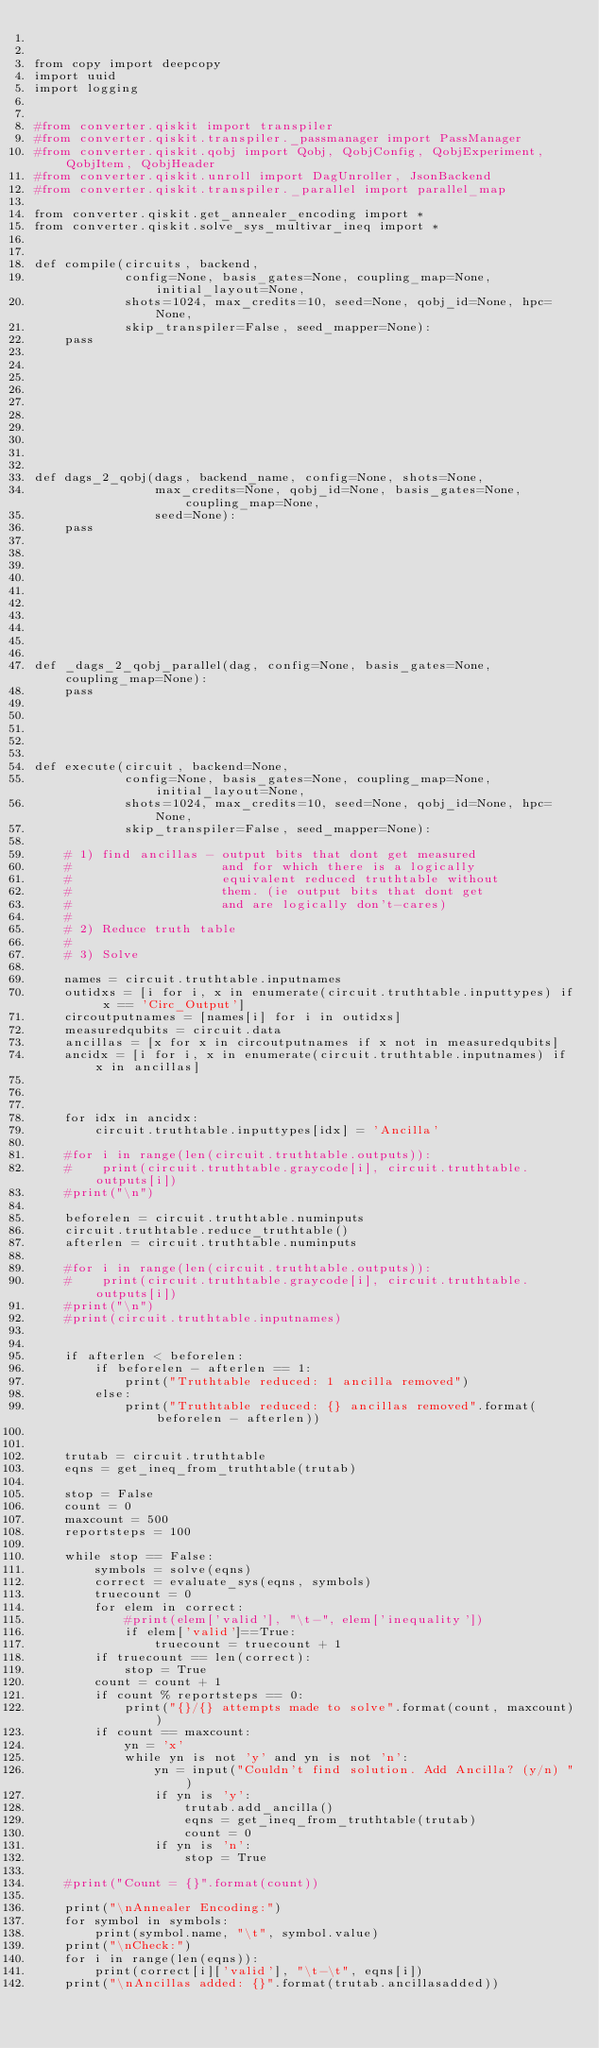Convert code to text. <code><loc_0><loc_0><loc_500><loc_500><_Python_>

from copy import deepcopy
import uuid
import logging


#from converter.qiskit import transpiler
#from converter.qiskit.transpiler._passmanager import PassManager
#from converter.qiskit.qobj import Qobj, QobjConfig, QobjExperiment, QobjItem, QobjHeader
#from converter.qiskit.unroll import DagUnroller, JsonBackend
#from converter.qiskit.transpiler._parallel import parallel_map

from converter.qiskit.get_annealer_encoding import *
from converter.qiskit.solve_sys_multivar_ineq import *


def compile(circuits, backend,
            config=None, basis_gates=None, coupling_map=None, initial_layout=None,
            shots=1024, max_credits=10, seed=None, qobj_id=None, hpc=None,
            skip_transpiler=False, seed_mapper=None):
    pass










def dags_2_qobj(dags, backend_name, config=None, shots=None,
                max_credits=None, qobj_id=None, basis_gates=None, coupling_map=None,
                seed=None):
    pass










def _dags_2_qobj_parallel(dag, config=None, basis_gates=None, coupling_map=None):
    pass





def execute(circuit, backend=None,
            config=None, basis_gates=None, coupling_map=None, initial_layout=None,
            shots=1024, max_credits=10, seed=None, qobj_id=None, hpc=None,
            skip_transpiler=False, seed_mapper=None):

    # 1) find ancillas - output bits that dont get measured
    #                    and for which there is a logically 
    #                    equivalent reduced truthtable without
    #                    them. (ie output bits that dont get 
    #                    and are logically don't-cares)
    # 
    # 2) Reduce truth table
    #
    # 3) Solve

    names = circuit.truthtable.inputnames
    outidxs = [i for i, x in enumerate(circuit.truthtable.inputtypes) if x == 'Circ_Output']
    circoutputnames = [names[i] for i in outidxs]
    measuredqubits = circuit.data
    ancillas = [x for x in circoutputnames if x not in measuredqubits]
    ancidx = [i for i, x in enumerate(circuit.truthtable.inputnames) if x in ancillas]

    

    for idx in ancidx:
        circuit.truthtable.inputtypes[idx] = 'Ancilla'

    #for i in range(len(circuit.truthtable.outputs)):
    #    print(circuit.truthtable.graycode[i], circuit.truthtable.outputs[i])
    #print("\n")
    
    beforelen = circuit.truthtable.numinputs
    circuit.truthtable.reduce_truthtable()
    afterlen = circuit.truthtable.numinputs

    #for i in range(len(circuit.truthtable.outputs)):
    #    print(circuit.truthtable.graycode[i], circuit.truthtable.outputs[i])
    #print("\n")
    #print(circuit.truthtable.inputnames)
    

    if afterlen < beforelen:
        if beforelen - afterlen == 1:
            print("Truthtable reduced: 1 ancilla removed")
        else:
            print("Truthtable reduced: {} ancillas removed".format(beforelen - afterlen))


    trutab = circuit.truthtable
    eqns = get_ineq_from_truthtable(trutab)

    stop = False
    count = 0
    maxcount = 500
    reportsteps = 100

    while stop == False:
        symbols = solve(eqns)
        correct = evaluate_sys(eqns, symbols)
        truecount = 0
        for elem in correct:
            #print(elem['valid'], "\t-", elem['inequality'])
            if elem['valid']==True:
                truecount = truecount + 1
        if truecount == len(correct):
            stop = True
        count = count + 1
        if count % reportsteps == 0:
            print("{}/{} attempts made to solve".format(count, maxcount))
        if count == maxcount:
            yn = 'x'
            while yn is not 'y' and yn is not 'n':
                yn = input("Couldn't find solution. Add Ancilla? (y/n) ")
                if yn is 'y':
                    trutab.add_ancilla()
                    eqns = get_ineq_from_truthtable(trutab)
                    count = 0
                if yn is 'n':
                    stop = True

    #print("Count = {}".format(count))

    print("\nAnnealer Encoding:")
    for symbol in symbols:
        print(symbol.name, "\t", symbol.value)
    print("\nCheck:")
    for i in range(len(eqns)):
        print(correct[i]['valid'], "\t-\t", eqns[i])
    print("\nAncillas added: {}".format(trutab.ancillasadded))


</code> 